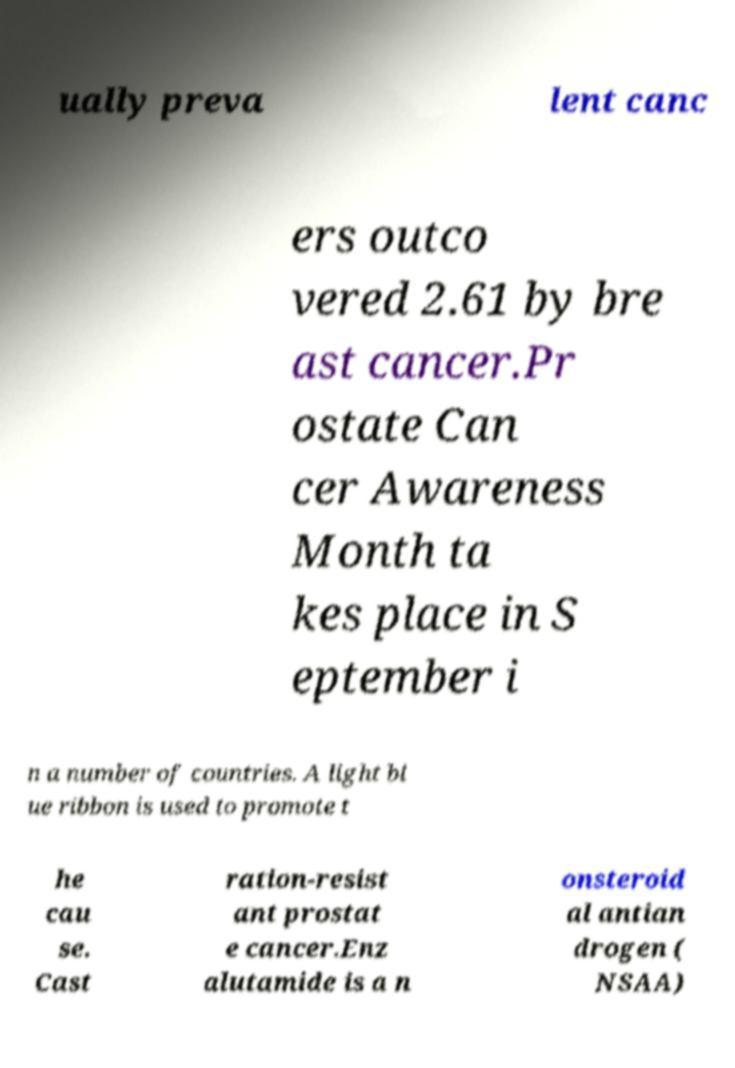What messages or text are displayed in this image? I need them in a readable, typed format. ually preva lent canc ers outco vered 2.61 by bre ast cancer.Pr ostate Can cer Awareness Month ta kes place in S eptember i n a number of countries. A light bl ue ribbon is used to promote t he cau se. Cast ration-resist ant prostat e cancer.Enz alutamide is a n onsteroid al antian drogen ( NSAA) 